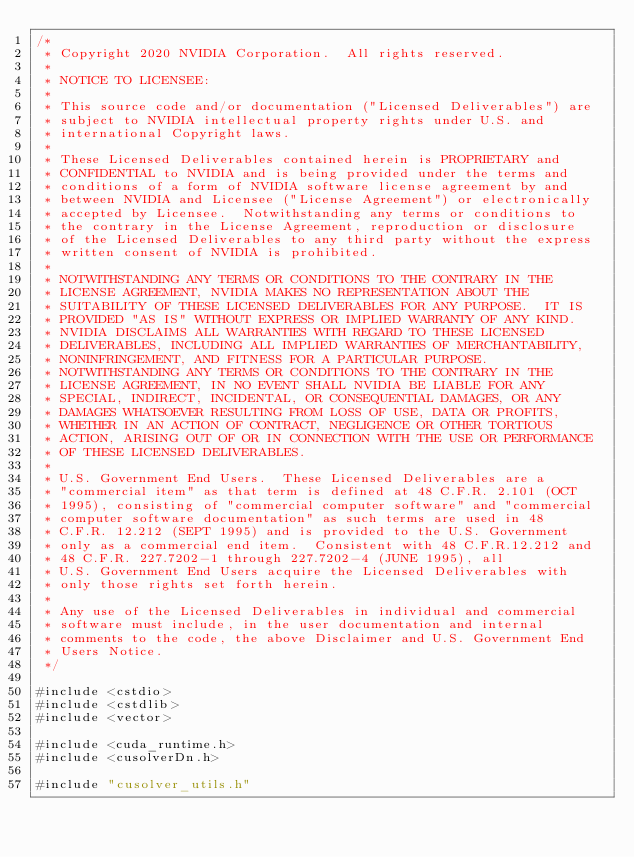Convert code to text. <code><loc_0><loc_0><loc_500><loc_500><_Cuda_>/*
 * Copyright 2020 NVIDIA Corporation.  All rights reserved.
 *
 * NOTICE TO LICENSEE:
 *
 * This source code and/or documentation ("Licensed Deliverables") are
 * subject to NVIDIA intellectual property rights under U.S. and
 * international Copyright laws.
 *
 * These Licensed Deliverables contained herein is PROPRIETARY and
 * CONFIDENTIAL to NVIDIA and is being provided under the terms and
 * conditions of a form of NVIDIA software license agreement by and
 * between NVIDIA and Licensee ("License Agreement") or electronically
 * accepted by Licensee.  Notwithstanding any terms or conditions to
 * the contrary in the License Agreement, reproduction or disclosure
 * of the Licensed Deliverables to any third party without the express
 * written consent of NVIDIA is prohibited.
 *
 * NOTWITHSTANDING ANY TERMS OR CONDITIONS TO THE CONTRARY IN THE
 * LICENSE AGREEMENT, NVIDIA MAKES NO REPRESENTATION ABOUT THE
 * SUITABILITY OF THESE LICENSED DELIVERABLES FOR ANY PURPOSE.  IT IS
 * PROVIDED "AS IS" WITHOUT EXPRESS OR IMPLIED WARRANTY OF ANY KIND.
 * NVIDIA DISCLAIMS ALL WARRANTIES WITH REGARD TO THESE LICENSED
 * DELIVERABLES, INCLUDING ALL IMPLIED WARRANTIES OF MERCHANTABILITY,
 * NONINFRINGEMENT, AND FITNESS FOR A PARTICULAR PURPOSE.
 * NOTWITHSTANDING ANY TERMS OR CONDITIONS TO THE CONTRARY IN THE
 * LICENSE AGREEMENT, IN NO EVENT SHALL NVIDIA BE LIABLE FOR ANY
 * SPECIAL, INDIRECT, INCIDENTAL, OR CONSEQUENTIAL DAMAGES, OR ANY
 * DAMAGES WHATSOEVER RESULTING FROM LOSS OF USE, DATA OR PROFITS,
 * WHETHER IN AN ACTION OF CONTRACT, NEGLIGENCE OR OTHER TORTIOUS
 * ACTION, ARISING OUT OF OR IN CONNECTION WITH THE USE OR PERFORMANCE
 * OF THESE LICENSED DELIVERABLES.
 *
 * U.S. Government End Users.  These Licensed Deliverables are a
 * "commercial item" as that term is defined at 48 C.F.R. 2.101 (OCT
 * 1995), consisting of "commercial computer software" and "commercial
 * computer software documentation" as such terms are used in 48
 * C.F.R. 12.212 (SEPT 1995) and is provided to the U.S. Government
 * only as a commercial end item.  Consistent with 48 C.F.R.12.212 and
 * 48 C.F.R. 227.7202-1 through 227.7202-4 (JUNE 1995), all
 * U.S. Government End Users acquire the Licensed Deliverables with
 * only those rights set forth herein.
 *
 * Any use of the Licensed Deliverables in individual and commercial
 * software must include, in the user documentation and internal
 * comments to the code, the above Disclaimer and U.S. Government End
 * Users Notice.
 */

#include <cstdio>
#include <cstdlib>
#include <vector>

#include <cuda_runtime.h>
#include <cusolverDn.h>

#include "cusolver_utils.h"
</code> 